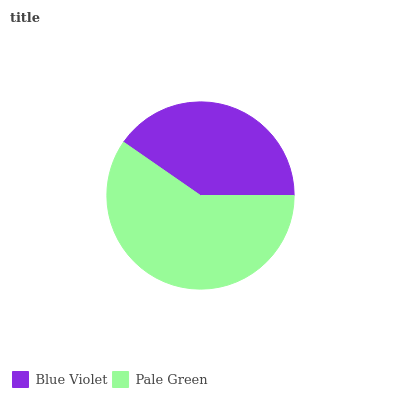Is Blue Violet the minimum?
Answer yes or no. Yes. Is Pale Green the maximum?
Answer yes or no. Yes. Is Pale Green the minimum?
Answer yes or no. No. Is Pale Green greater than Blue Violet?
Answer yes or no. Yes. Is Blue Violet less than Pale Green?
Answer yes or no. Yes. Is Blue Violet greater than Pale Green?
Answer yes or no. No. Is Pale Green less than Blue Violet?
Answer yes or no. No. Is Pale Green the high median?
Answer yes or no. Yes. Is Blue Violet the low median?
Answer yes or no. Yes. Is Blue Violet the high median?
Answer yes or no. No. Is Pale Green the low median?
Answer yes or no. No. 